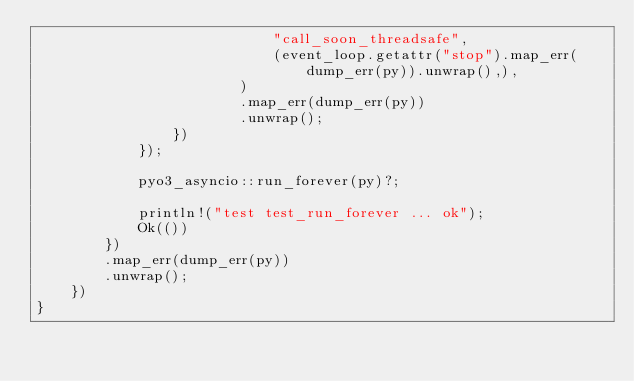Convert code to text. <code><loc_0><loc_0><loc_500><loc_500><_Rust_>                            "call_soon_threadsafe",
                            (event_loop.getattr("stop").map_err(dump_err(py)).unwrap(),),
                        )
                        .map_err(dump_err(py))
                        .unwrap();
                })
            });

            pyo3_asyncio::run_forever(py)?;

            println!("test test_run_forever ... ok");
            Ok(())
        })
        .map_err(dump_err(py))
        .unwrap();
    })
}
</code> 